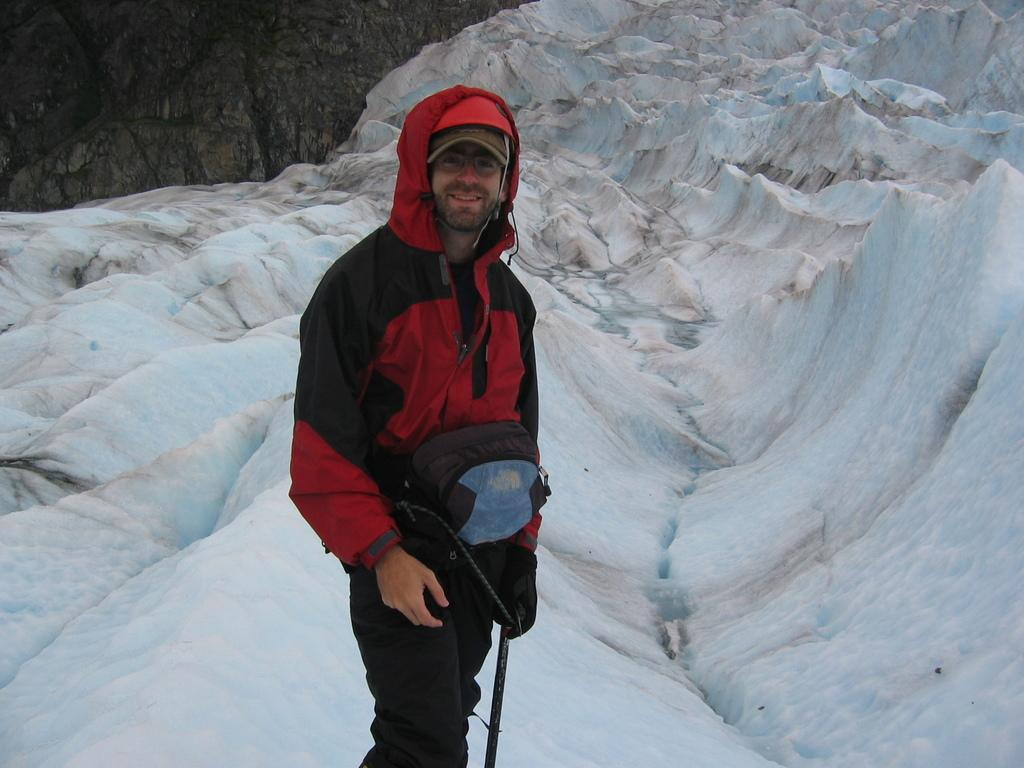What is the main subject of the image? There is a man standing in the image. What is the man wearing? The man is wearing a jacket. What can be seen in the background of the image? There are hills and snow visible in the background of the image. What town is visible in the image? There is no town visible in the image; it features a man standing in front of hills with snow in the background. 